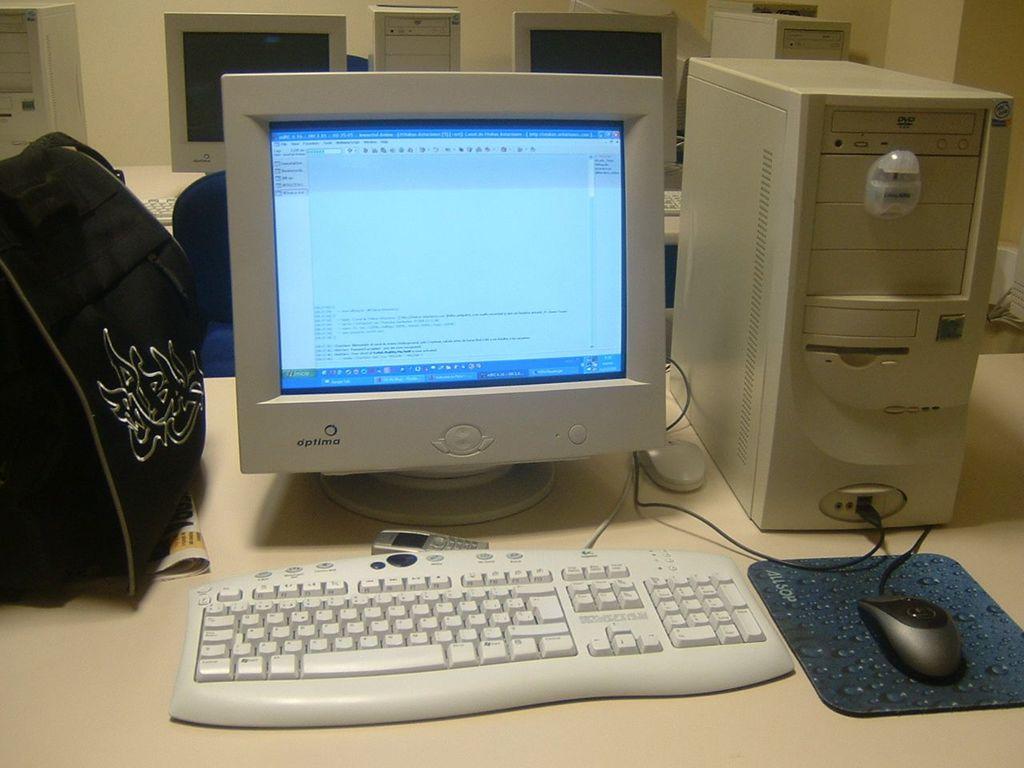What brand of desktop computer is on the table?
Offer a very short reply. Optima. What company name is on the mouse pad?
Give a very brief answer. Allsop. 